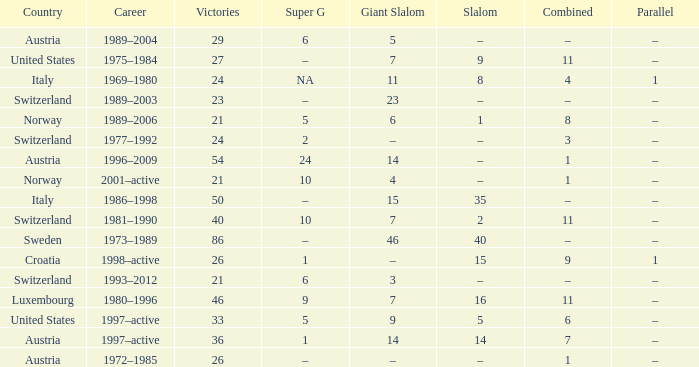Can you parse all the data within this table? {'header': ['Country', 'Career', 'Victories', 'Super G', 'Giant Slalom', 'Slalom', 'Combined', 'Parallel'], 'rows': [['Austria', '1989–2004', '29', '6', '5', '–', '–', '–'], ['United States', '1975–1984', '27', '–', '7', '9', '11', '–'], ['Italy', '1969–1980', '24', 'NA', '11', '8', '4', '1'], ['Switzerland', '1989–2003', '23', '–', '23', '–', '–', '–'], ['Norway', '1989–2006', '21', '5', '6', '1', '8', '–'], ['Switzerland', '1977–1992', '24', '2', '–', '–', '3', '–'], ['Austria', '1996–2009', '54', '24', '14', '–', '1', '–'], ['Norway', '2001–active', '21', '10', '4', '–', '1', '–'], ['Italy', '1986–1998', '50', '–', '15', '35', '–', '–'], ['Switzerland', '1981–1990', '40', '10', '7', '2', '11', '–'], ['Sweden', '1973–1989', '86', '–', '46', '40', '–', '–'], ['Croatia', '1998–active', '26', '1', '–', '15', '9', '1'], ['Switzerland', '1993–2012', '21', '6', '3', '–', '–', '–'], ['Luxembourg', '1980–1996', '46', '9', '7', '16', '11', '–'], ['United States', '1997–active', '33', '5', '9', '5', '6', '–'], ['Austria', '1997–active', '36', '1', '14', '14', '7', '–'], ['Austria', '1972–1985', '26', '–', '–', '–', '1', '–']]} What Super G has Victories of 26, and a Country of austria? –. 